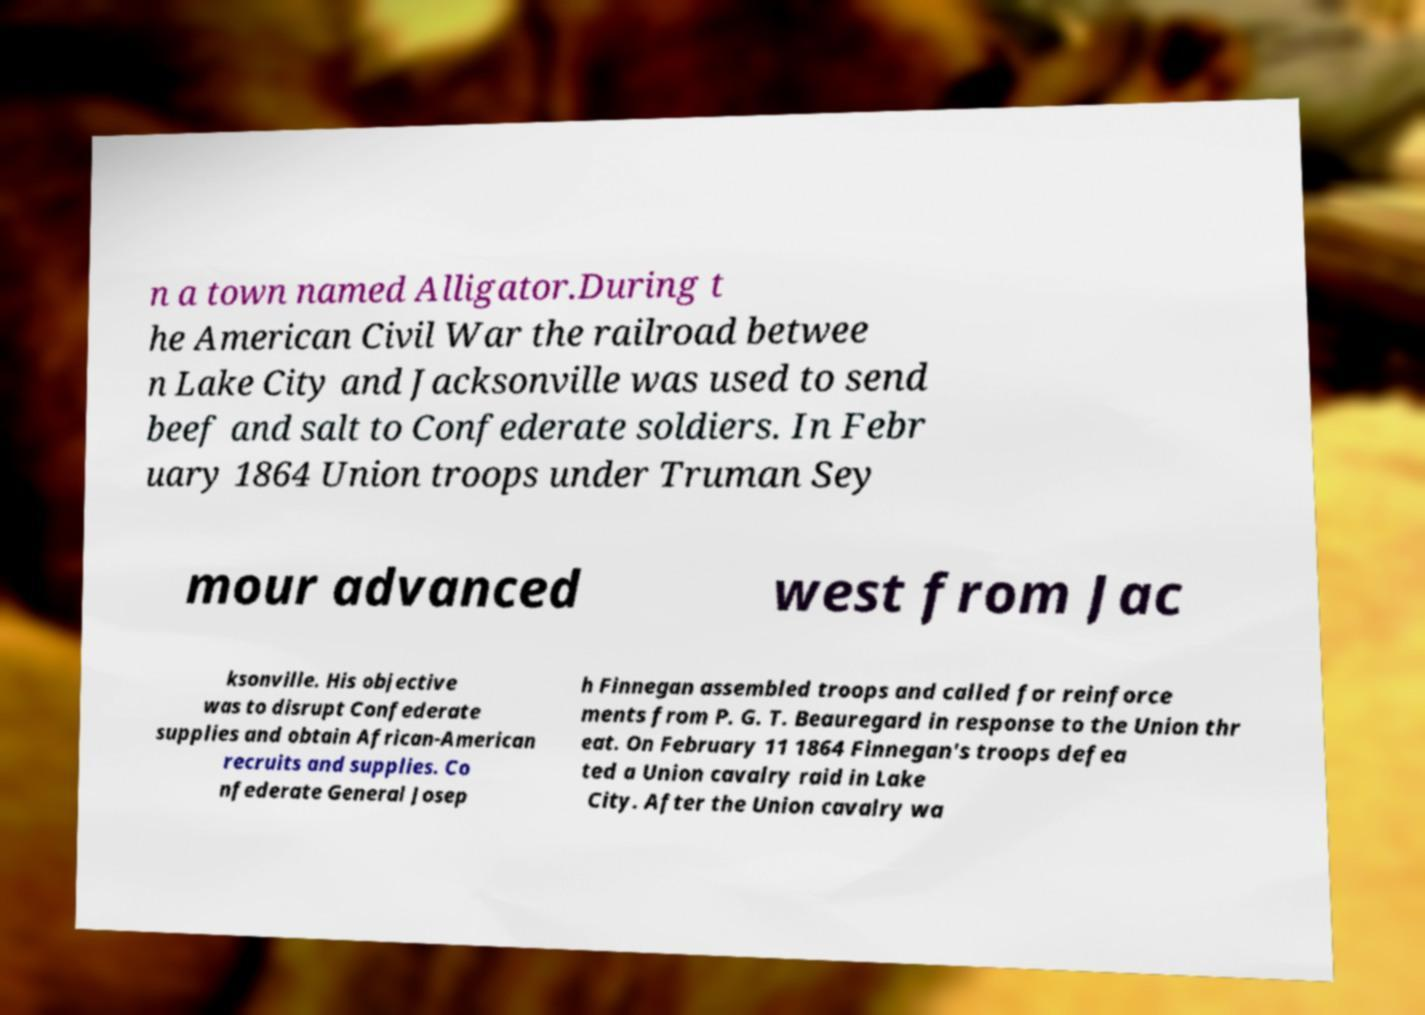Can you read and provide the text displayed in the image?This photo seems to have some interesting text. Can you extract and type it out for me? n a town named Alligator.During t he American Civil War the railroad betwee n Lake City and Jacksonville was used to send beef and salt to Confederate soldiers. In Febr uary 1864 Union troops under Truman Sey mour advanced west from Jac ksonville. His objective was to disrupt Confederate supplies and obtain African-American recruits and supplies. Co nfederate General Josep h Finnegan assembled troops and called for reinforce ments from P. G. T. Beauregard in response to the Union thr eat. On February 11 1864 Finnegan's troops defea ted a Union cavalry raid in Lake City. After the Union cavalry wa 